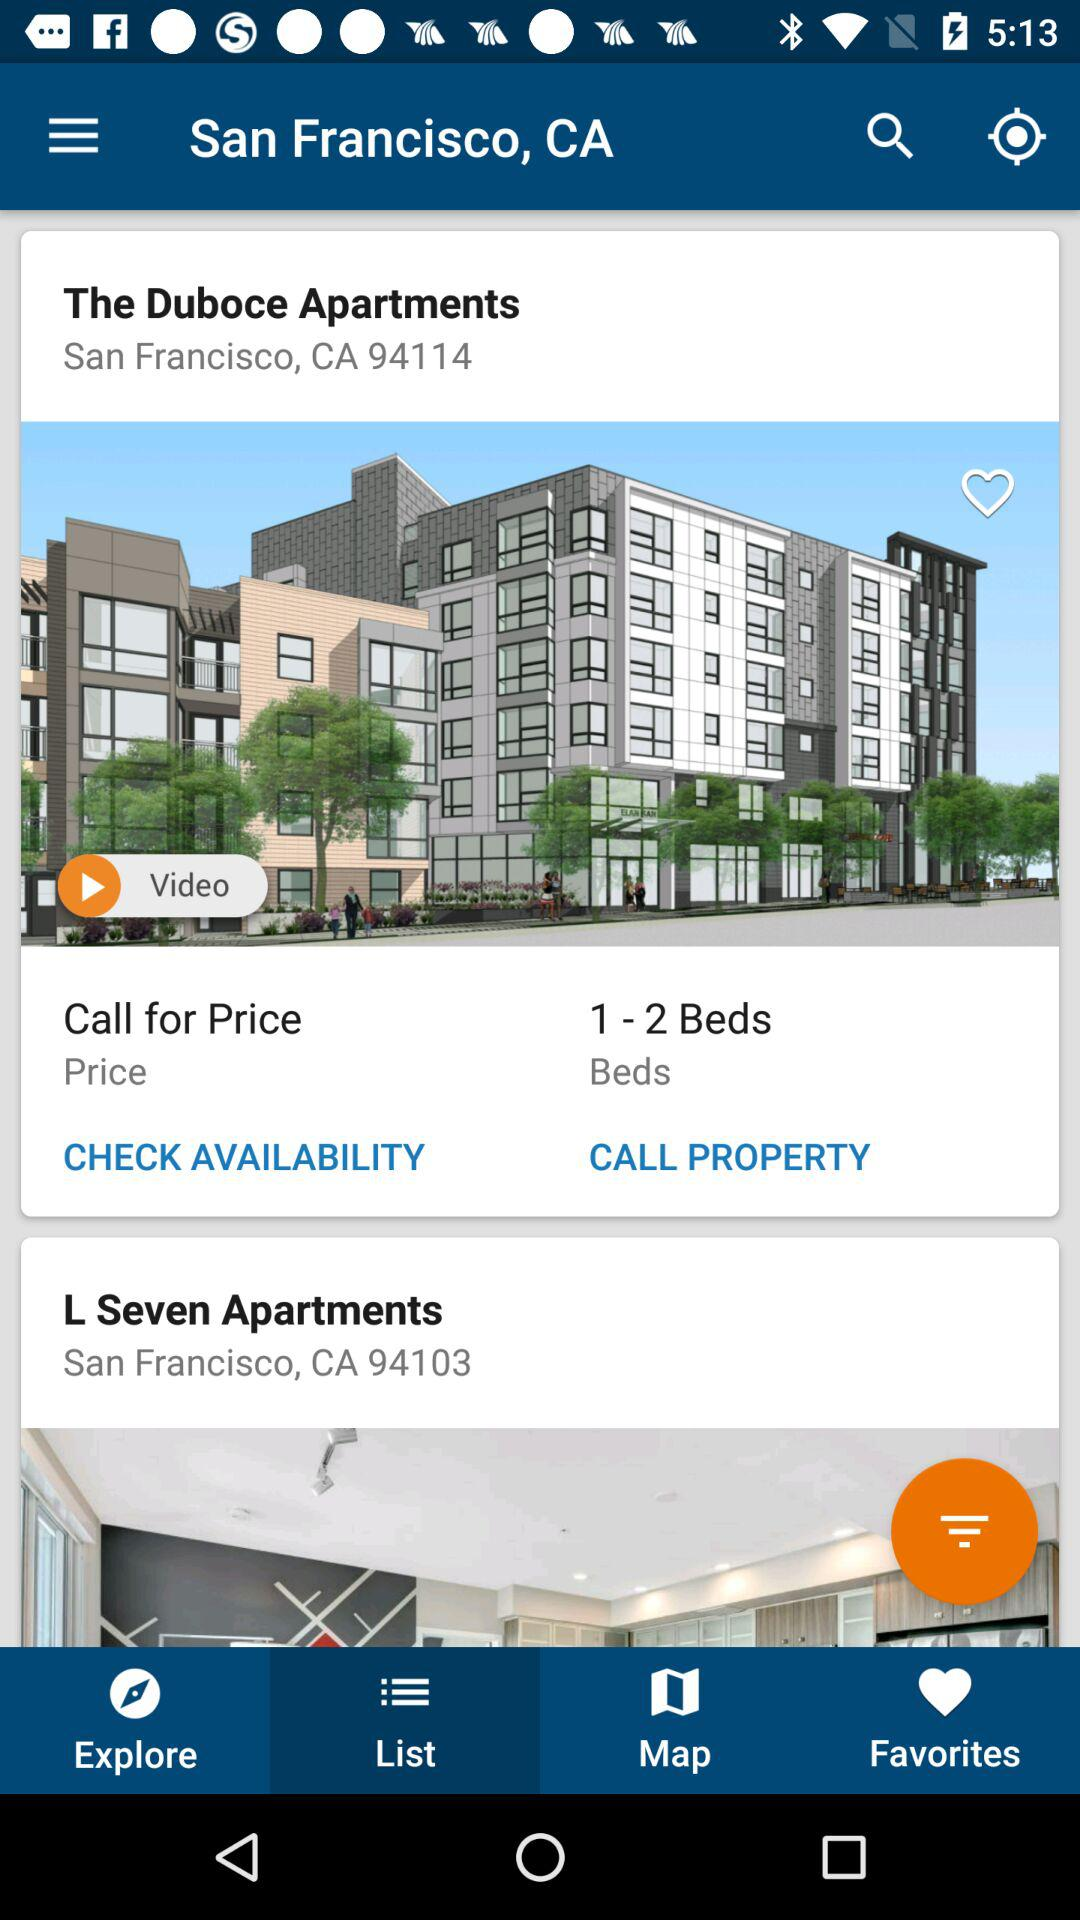Where are "The Duboce Apartments" located? "The Duboce Apartments" are located in San Francisco, CA 94114. 